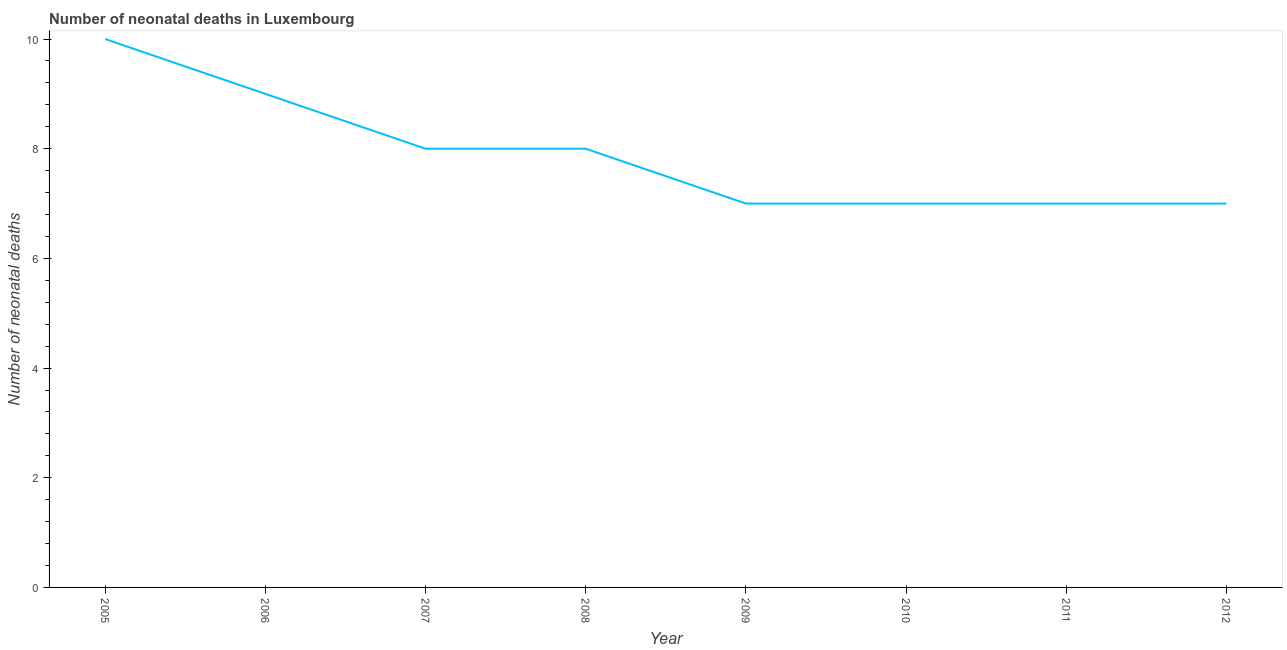What is the number of neonatal deaths in 2005?
Offer a very short reply. 10. Across all years, what is the maximum number of neonatal deaths?
Offer a very short reply. 10. Across all years, what is the minimum number of neonatal deaths?
Your answer should be very brief. 7. In which year was the number of neonatal deaths maximum?
Keep it short and to the point. 2005. In which year was the number of neonatal deaths minimum?
Your response must be concise. 2009. What is the sum of the number of neonatal deaths?
Your answer should be very brief. 63. What is the difference between the number of neonatal deaths in 2007 and 2012?
Provide a short and direct response. 1. What is the average number of neonatal deaths per year?
Offer a terse response. 7.88. What is the median number of neonatal deaths?
Offer a terse response. 7.5. What is the ratio of the number of neonatal deaths in 2005 to that in 2007?
Give a very brief answer. 1.25. Is the difference between the number of neonatal deaths in 2011 and 2012 greater than the difference between any two years?
Make the answer very short. No. What is the difference between the highest and the lowest number of neonatal deaths?
Offer a very short reply. 3. How many years are there in the graph?
Your answer should be compact. 8. What is the difference between two consecutive major ticks on the Y-axis?
Offer a terse response. 2. Are the values on the major ticks of Y-axis written in scientific E-notation?
Ensure brevity in your answer.  No. Does the graph contain any zero values?
Your answer should be compact. No. What is the title of the graph?
Offer a very short reply. Number of neonatal deaths in Luxembourg. What is the label or title of the Y-axis?
Your response must be concise. Number of neonatal deaths. What is the Number of neonatal deaths of 2006?
Your answer should be compact. 9. What is the Number of neonatal deaths of 2007?
Offer a terse response. 8. What is the Number of neonatal deaths of 2009?
Your answer should be very brief. 7. What is the Number of neonatal deaths in 2010?
Ensure brevity in your answer.  7. What is the Number of neonatal deaths of 2012?
Give a very brief answer. 7. What is the difference between the Number of neonatal deaths in 2005 and 2007?
Your answer should be very brief. 2. What is the difference between the Number of neonatal deaths in 2006 and 2007?
Give a very brief answer. 1. What is the difference between the Number of neonatal deaths in 2006 and 2008?
Your answer should be compact. 1. What is the difference between the Number of neonatal deaths in 2006 and 2010?
Give a very brief answer. 2. What is the difference between the Number of neonatal deaths in 2006 and 2011?
Provide a succinct answer. 2. What is the difference between the Number of neonatal deaths in 2006 and 2012?
Offer a very short reply. 2. What is the difference between the Number of neonatal deaths in 2007 and 2008?
Keep it short and to the point. 0. What is the difference between the Number of neonatal deaths in 2007 and 2010?
Make the answer very short. 1. What is the difference between the Number of neonatal deaths in 2007 and 2011?
Provide a short and direct response. 1. What is the difference between the Number of neonatal deaths in 2007 and 2012?
Offer a very short reply. 1. What is the difference between the Number of neonatal deaths in 2008 and 2009?
Provide a short and direct response. 1. What is the difference between the Number of neonatal deaths in 2008 and 2011?
Your response must be concise. 1. What is the difference between the Number of neonatal deaths in 2009 and 2011?
Provide a succinct answer. 0. What is the difference between the Number of neonatal deaths in 2011 and 2012?
Make the answer very short. 0. What is the ratio of the Number of neonatal deaths in 2005 to that in 2006?
Provide a short and direct response. 1.11. What is the ratio of the Number of neonatal deaths in 2005 to that in 2008?
Your response must be concise. 1.25. What is the ratio of the Number of neonatal deaths in 2005 to that in 2009?
Make the answer very short. 1.43. What is the ratio of the Number of neonatal deaths in 2005 to that in 2010?
Offer a very short reply. 1.43. What is the ratio of the Number of neonatal deaths in 2005 to that in 2011?
Keep it short and to the point. 1.43. What is the ratio of the Number of neonatal deaths in 2005 to that in 2012?
Ensure brevity in your answer.  1.43. What is the ratio of the Number of neonatal deaths in 2006 to that in 2007?
Provide a succinct answer. 1.12. What is the ratio of the Number of neonatal deaths in 2006 to that in 2008?
Offer a terse response. 1.12. What is the ratio of the Number of neonatal deaths in 2006 to that in 2009?
Your response must be concise. 1.29. What is the ratio of the Number of neonatal deaths in 2006 to that in 2010?
Make the answer very short. 1.29. What is the ratio of the Number of neonatal deaths in 2006 to that in 2011?
Provide a short and direct response. 1.29. What is the ratio of the Number of neonatal deaths in 2006 to that in 2012?
Give a very brief answer. 1.29. What is the ratio of the Number of neonatal deaths in 2007 to that in 2008?
Offer a terse response. 1. What is the ratio of the Number of neonatal deaths in 2007 to that in 2009?
Your answer should be very brief. 1.14. What is the ratio of the Number of neonatal deaths in 2007 to that in 2010?
Give a very brief answer. 1.14. What is the ratio of the Number of neonatal deaths in 2007 to that in 2011?
Ensure brevity in your answer.  1.14. What is the ratio of the Number of neonatal deaths in 2007 to that in 2012?
Give a very brief answer. 1.14. What is the ratio of the Number of neonatal deaths in 2008 to that in 2009?
Your answer should be very brief. 1.14. What is the ratio of the Number of neonatal deaths in 2008 to that in 2010?
Your answer should be compact. 1.14. What is the ratio of the Number of neonatal deaths in 2008 to that in 2011?
Your answer should be compact. 1.14. What is the ratio of the Number of neonatal deaths in 2008 to that in 2012?
Make the answer very short. 1.14. What is the ratio of the Number of neonatal deaths in 2009 to that in 2010?
Your answer should be very brief. 1. What is the ratio of the Number of neonatal deaths in 2009 to that in 2011?
Provide a succinct answer. 1. What is the ratio of the Number of neonatal deaths in 2010 to that in 2012?
Keep it short and to the point. 1. What is the ratio of the Number of neonatal deaths in 2011 to that in 2012?
Offer a very short reply. 1. 